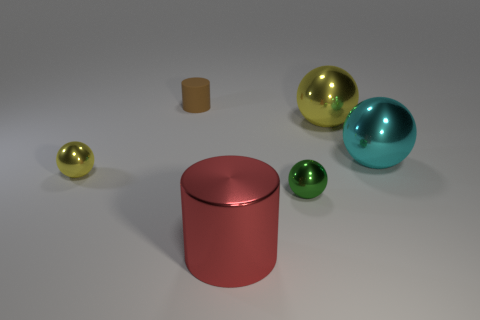Are there more yellow things that are left of the tiny green thing than yellow objects to the right of the large cyan metallic ball? Upon closer examination of the image, it appears that there are two yellow objects to the left of the tiny green sphere, whereas there is only one yellow object to the right of the large cyan metallic ball. So yes, there are indeed more yellow things located to the left of the tiny green object in comparison to the right side of the cyan ball. 